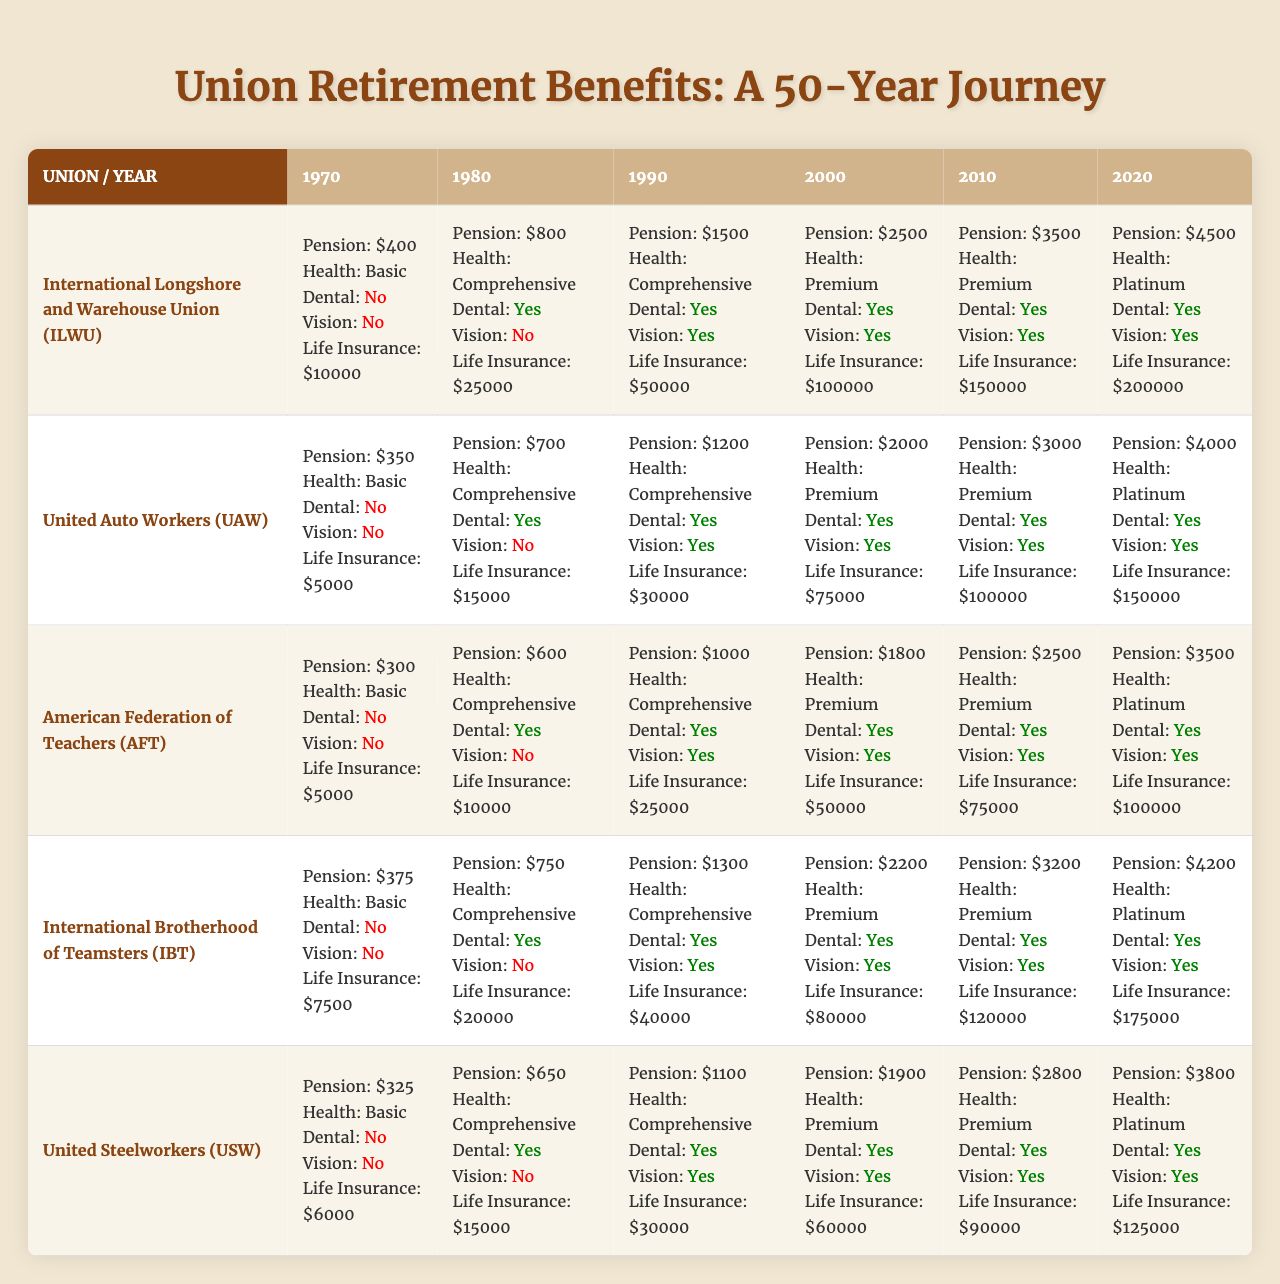What was the pension amount for the United Auto Workers in 2000? The table indicates that in the year 2000, the pension amount for the United Auto Workers was $2000 per month.
Answer: $2000 Which union had the highest life insurance coverage in 2020? By reviewing the table, the International Longshore and Warehouse Union has the highest life insurance coverage in 2020 at $200,000.
Answer: International Longshore and Warehouse Union Did the American Federation of Teachers offer dental coverage in 1970? The data shows that the American Federation of Teachers did not provide dental coverage in 1970, as indicated by "false" in that year’s column.
Answer: No What was the increase in monthly pension for the International Brotherhood of Teamsters from 1990 to 2000? The monthly pension for the International Brotherhood of Teamsters in 1990 was $1300, and in 2000 it was $2200. The increase is calculated as $2200 - $1300 = $900.
Answer: $900 What percentage of the unions had comprehensive health coverage in 1990? In 1990, all unions except for the United Steelworkers had comprehensive health coverage. This means 4 out of 5 unions had this type of coverage, which calculates to (4/5) * 100 = 80%.
Answer: 80% Which union had the least pension amount in 1970, and what was it? Upon checking the table, the United Steelworkers had the least pension amount in 1970 at $325.
Answer: United Steelworkers, $325 Was there a union that offered vision coverage in 1980? According to the table, only the United Auto Workers and the International Brotherhood of Teamsters provided vision coverage in 1980, as indicated by "true" for those unions.
Answer: Yes What is the average pension amount across all unions in 2020? To find the average pension amount in 2020, sum the pension amounts: $4500 (ILWU) + $4000 (UAW) + $3500 (AFT) + $4200 (IBT) + $3800 (USW) = $19800, then divide by 5 unions: $19800 / 5 = $3960.
Answer: $3960 What was the change in health coverage type from 1970 to 2020 for the International Longshore and Warehouse Union? In 1970, the health coverage was "Basic," and by 2020, it changed to "Platinum," indicating a progression from the lowest to the highest level of coverage.
Answer: From Basic to Platinum Which years did the United Steelworkers have premium health coverage? According to the data, the United Steelworkers had premium health coverage in the years 2000, 2010, and 2020 while their health coverage in 1970 and 1980 was Basic and Comprehensive, respectively.
Answer: 2000, 2010, 2020 